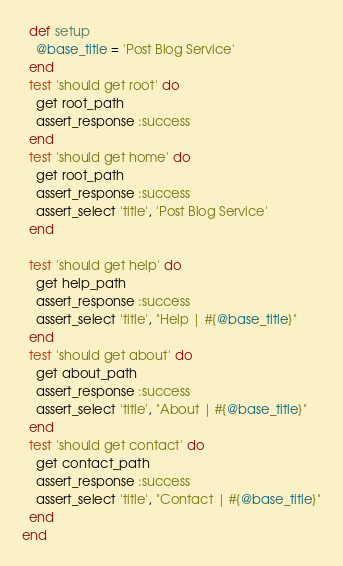Convert code to text. <code><loc_0><loc_0><loc_500><loc_500><_Ruby_>  def setup
    @base_title = 'Post Blog Service'
  end
  test 'should get root' do
    get root_path
    assert_response :success
  end
  test 'should get home' do
    get root_path
    assert_response :success
    assert_select 'title', 'Post Blog Service'
  end

  test 'should get help' do
    get help_path
    assert_response :success
    assert_select 'title', "Help | #{@base_title}"
  end
  test 'should get about' do
    get about_path
    assert_response :success
    assert_select 'title', "About | #{@base_title}"
  end
  test 'should get contact' do
    get contact_path
    assert_response :success
    assert_select 'title', "Contact | #{@base_title}"
  end
end
</code> 